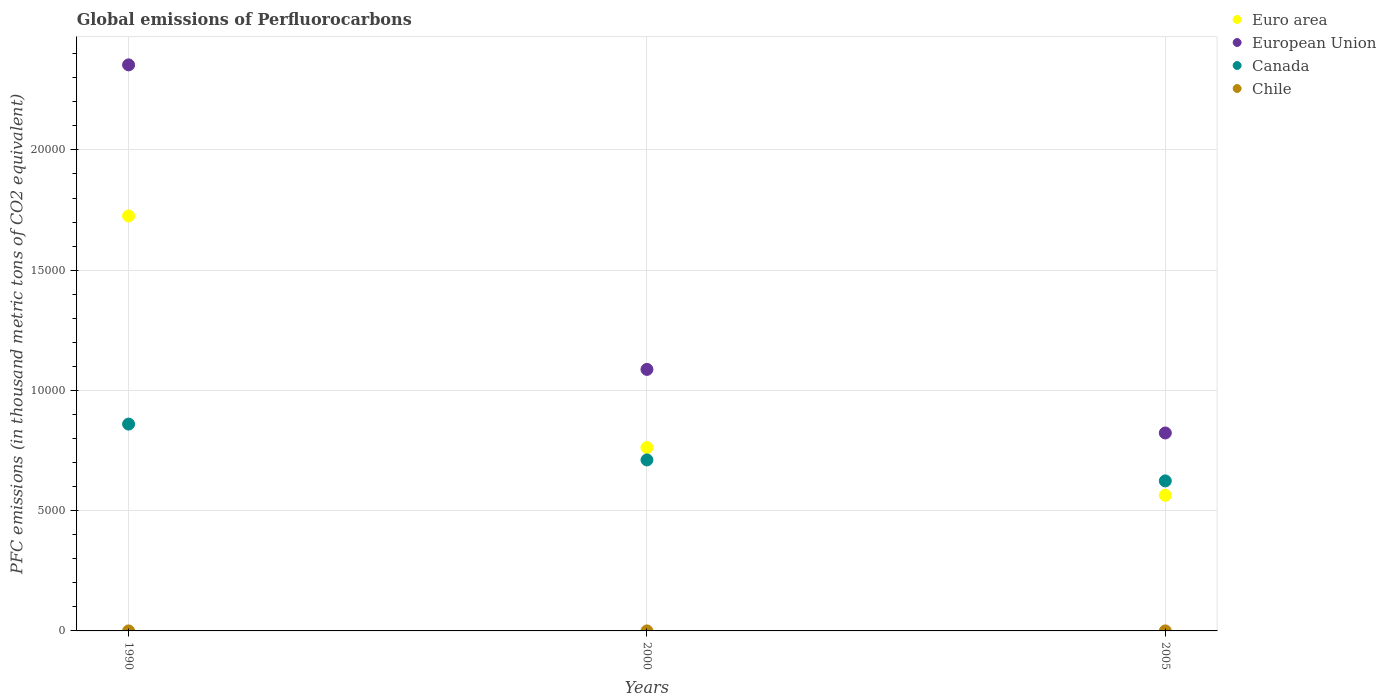What is the global emissions of Perfluorocarbons in Canada in 2005?
Make the answer very short. 6238. Across all years, what is the maximum global emissions of Perfluorocarbons in Canada?
Ensure brevity in your answer.  8600.3. What is the total global emissions of Perfluorocarbons in European Union in the graph?
Offer a very short reply. 4.26e+04. What is the difference between the global emissions of Perfluorocarbons in Canada in 1990 and that in 2005?
Ensure brevity in your answer.  2362.3. What is the difference between the global emissions of Perfluorocarbons in Chile in 1990 and the global emissions of Perfluorocarbons in European Union in 2005?
Offer a very short reply. -8230.59. What is the average global emissions of Perfluorocarbons in Canada per year?
Offer a very short reply. 7316.07. In the year 2000, what is the difference between the global emissions of Perfluorocarbons in Chile and global emissions of Perfluorocarbons in European Union?
Keep it short and to the point. -1.09e+04. What is the ratio of the global emissions of Perfluorocarbons in European Union in 2000 to that in 2005?
Your answer should be compact. 1.32. What is the difference between the highest and the second highest global emissions of Perfluorocarbons in Canada?
Offer a terse response. 1490.4. What is the difference between the highest and the lowest global emissions of Perfluorocarbons in Euro area?
Offer a terse response. 1.16e+04. Is it the case that in every year, the sum of the global emissions of Perfluorocarbons in Euro area and global emissions of Perfluorocarbons in Canada  is greater than the sum of global emissions of Perfluorocarbons in Chile and global emissions of Perfluorocarbons in European Union?
Make the answer very short. No. Is it the case that in every year, the sum of the global emissions of Perfluorocarbons in Canada and global emissions of Perfluorocarbons in Euro area  is greater than the global emissions of Perfluorocarbons in Chile?
Provide a short and direct response. Yes. Does the global emissions of Perfluorocarbons in Canada monotonically increase over the years?
Keep it short and to the point. No. Is the global emissions of Perfluorocarbons in Euro area strictly greater than the global emissions of Perfluorocarbons in European Union over the years?
Your answer should be compact. No. Is the global emissions of Perfluorocarbons in Euro area strictly less than the global emissions of Perfluorocarbons in Canada over the years?
Provide a succinct answer. No. How many dotlines are there?
Keep it short and to the point. 4. How many years are there in the graph?
Give a very brief answer. 3. Does the graph contain any zero values?
Offer a terse response. No. Where does the legend appear in the graph?
Offer a terse response. Top right. What is the title of the graph?
Keep it short and to the point. Global emissions of Perfluorocarbons. What is the label or title of the X-axis?
Make the answer very short. Years. What is the label or title of the Y-axis?
Offer a terse response. PFC emissions (in thousand metric tons of CO2 equivalent). What is the PFC emissions (in thousand metric tons of CO2 equivalent) in Euro area in 1990?
Your answer should be very brief. 1.73e+04. What is the PFC emissions (in thousand metric tons of CO2 equivalent) of European Union in 1990?
Your answer should be very brief. 2.35e+04. What is the PFC emissions (in thousand metric tons of CO2 equivalent) in Canada in 1990?
Keep it short and to the point. 8600.3. What is the PFC emissions (in thousand metric tons of CO2 equivalent) in Euro area in 2000?
Give a very brief answer. 7625. What is the PFC emissions (in thousand metric tons of CO2 equivalent) of European Union in 2000?
Make the answer very short. 1.09e+04. What is the PFC emissions (in thousand metric tons of CO2 equivalent) of Canada in 2000?
Offer a terse response. 7109.9. What is the PFC emissions (in thousand metric tons of CO2 equivalent) in Euro area in 2005?
Your answer should be very brief. 5640.06. What is the PFC emissions (in thousand metric tons of CO2 equivalent) of European Union in 2005?
Keep it short and to the point. 8230.79. What is the PFC emissions (in thousand metric tons of CO2 equivalent) of Canada in 2005?
Your response must be concise. 6238. Across all years, what is the maximum PFC emissions (in thousand metric tons of CO2 equivalent) in Euro area?
Offer a very short reply. 1.73e+04. Across all years, what is the maximum PFC emissions (in thousand metric tons of CO2 equivalent) of European Union?
Your response must be concise. 2.35e+04. Across all years, what is the maximum PFC emissions (in thousand metric tons of CO2 equivalent) of Canada?
Your answer should be compact. 8600.3. Across all years, what is the maximum PFC emissions (in thousand metric tons of CO2 equivalent) of Chile?
Provide a short and direct response. 0.2. Across all years, what is the minimum PFC emissions (in thousand metric tons of CO2 equivalent) of Euro area?
Make the answer very short. 5640.06. Across all years, what is the minimum PFC emissions (in thousand metric tons of CO2 equivalent) in European Union?
Your answer should be compact. 8230.79. Across all years, what is the minimum PFC emissions (in thousand metric tons of CO2 equivalent) of Canada?
Make the answer very short. 6238. What is the total PFC emissions (in thousand metric tons of CO2 equivalent) in Euro area in the graph?
Your answer should be compact. 3.05e+04. What is the total PFC emissions (in thousand metric tons of CO2 equivalent) of European Union in the graph?
Ensure brevity in your answer.  4.26e+04. What is the total PFC emissions (in thousand metric tons of CO2 equivalent) in Canada in the graph?
Offer a very short reply. 2.19e+04. What is the difference between the PFC emissions (in thousand metric tons of CO2 equivalent) of Euro area in 1990 and that in 2000?
Provide a succinct answer. 9630.1. What is the difference between the PFC emissions (in thousand metric tons of CO2 equivalent) in European Union in 1990 and that in 2000?
Offer a very short reply. 1.27e+04. What is the difference between the PFC emissions (in thousand metric tons of CO2 equivalent) in Canada in 1990 and that in 2000?
Your answer should be very brief. 1490.4. What is the difference between the PFC emissions (in thousand metric tons of CO2 equivalent) in Chile in 1990 and that in 2000?
Your answer should be very brief. 0. What is the difference between the PFC emissions (in thousand metric tons of CO2 equivalent) in Euro area in 1990 and that in 2005?
Ensure brevity in your answer.  1.16e+04. What is the difference between the PFC emissions (in thousand metric tons of CO2 equivalent) of European Union in 1990 and that in 2005?
Offer a very short reply. 1.53e+04. What is the difference between the PFC emissions (in thousand metric tons of CO2 equivalent) in Canada in 1990 and that in 2005?
Provide a succinct answer. 2362.3. What is the difference between the PFC emissions (in thousand metric tons of CO2 equivalent) in Chile in 1990 and that in 2005?
Make the answer very short. 0. What is the difference between the PFC emissions (in thousand metric tons of CO2 equivalent) of Euro area in 2000 and that in 2005?
Offer a terse response. 1984.94. What is the difference between the PFC emissions (in thousand metric tons of CO2 equivalent) in European Union in 2000 and that in 2005?
Ensure brevity in your answer.  2643.81. What is the difference between the PFC emissions (in thousand metric tons of CO2 equivalent) of Canada in 2000 and that in 2005?
Your answer should be very brief. 871.9. What is the difference between the PFC emissions (in thousand metric tons of CO2 equivalent) in Euro area in 1990 and the PFC emissions (in thousand metric tons of CO2 equivalent) in European Union in 2000?
Provide a succinct answer. 6380.5. What is the difference between the PFC emissions (in thousand metric tons of CO2 equivalent) of Euro area in 1990 and the PFC emissions (in thousand metric tons of CO2 equivalent) of Canada in 2000?
Your answer should be very brief. 1.01e+04. What is the difference between the PFC emissions (in thousand metric tons of CO2 equivalent) of Euro area in 1990 and the PFC emissions (in thousand metric tons of CO2 equivalent) of Chile in 2000?
Your answer should be compact. 1.73e+04. What is the difference between the PFC emissions (in thousand metric tons of CO2 equivalent) of European Union in 1990 and the PFC emissions (in thousand metric tons of CO2 equivalent) of Canada in 2000?
Offer a very short reply. 1.64e+04. What is the difference between the PFC emissions (in thousand metric tons of CO2 equivalent) of European Union in 1990 and the PFC emissions (in thousand metric tons of CO2 equivalent) of Chile in 2000?
Provide a short and direct response. 2.35e+04. What is the difference between the PFC emissions (in thousand metric tons of CO2 equivalent) of Canada in 1990 and the PFC emissions (in thousand metric tons of CO2 equivalent) of Chile in 2000?
Offer a very short reply. 8600.1. What is the difference between the PFC emissions (in thousand metric tons of CO2 equivalent) of Euro area in 1990 and the PFC emissions (in thousand metric tons of CO2 equivalent) of European Union in 2005?
Keep it short and to the point. 9024.31. What is the difference between the PFC emissions (in thousand metric tons of CO2 equivalent) of Euro area in 1990 and the PFC emissions (in thousand metric tons of CO2 equivalent) of Canada in 2005?
Give a very brief answer. 1.10e+04. What is the difference between the PFC emissions (in thousand metric tons of CO2 equivalent) in Euro area in 1990 and the PFC emissions (in thousand metric tons of CO2 equivalent) in Chile in 2005?
Your response must be concise. 1.73e+04. What is the difference between the PFC emissions (in thousand metric tons of CO2 equivalent) in European Union in 1990 and the PFC emissions (in thousand metric tons of CO2 equivalent) in Canada in 2005?
Your answer should be compact. 1.73e+04. What is the difference between the PFC emissions (in thousand metric tons of CO2 equivalent) in European Union in 1990 and the PFC emissions (in thousand metric tons of CO2 equivalent) in Chile in 2005?
Your answer should be compact. 2.35e+04. What is the difference between the PFC emissions (in thousand metric tons of CO2 equivalent) in Canada in 1990 and the PFC emissions (in thousand metric tons of CO2 equivalent) in Chile in 2005?
Your response must be concise. 8600.1. What is the difference between the PFC emissions (in thousand metric tons of CO2 equivalent) in Euro area in 2000 and the PFC emissions (in thousand metric tons of CO2 equivalent) in European Union in 2005?
Keep it short and to the point. -605.79. What is the difference between the PFC emissions (in thousand metric tons of CO2 equivalent) in Euro area in 2000 and the PFC emissions (in thousand metric tons of CO2 equivalent) in Canada in 2005?
Make the answer very short. 1387. What is the difference between the PFC emissions (in thousand metric tons of CO2 equivalent) of Euro area in 2000 and the PFC emissions (in thousand metric tons of CO2 equivalent) of Chile in 2005?
Your response must be concise. 7624.8. What is the difference between the PFC emissions (in thousand metric tons of CO2 equivalent) of European Union in 2000 and the PFC emissions (in thousand metric tons of CO2 equivalent) of Canada in 2005?
Make the answer very short. 4636.6. What is the difference between the PFC emissions (in thousand metric tons of CO2 equivalent) of European Union in 2000 and the PFC emissions (in thousand metric tons of CO2 equivalent) of Chile in 2005?
Your answer should be compact. 1.09e+04. What is the difference between the PFC emissions (in thousand metric tons of CO2 equivalent) of Canada in 2000 and the PFC emissions (in thousand metric tons of CO2 equivalent) of Chile in 2005?
Provide a short and direct response. 7109.7. What is the average PFC emissions (in thousand metric tons of CO2 equivalent) of Euro area per year?
Provide a succinct answer. 1.02e+04. What is the average PFC emissions (in thousand metric tons of CO2 equivalent) of European Union per year?
Provide a succinct answer. 1.42e+04. What is the average PFC emissions (in thousand metric tons of CO2 equivalent) of Canada per year?
Provide a succinct answer. 7316.07. What is the average PFC emissions (in thousand metric tons of CO2 equivalent) in Chile per year?
Ensure brevity in your answer.  0.2. In the year 1990, what is the difference between the PFC emissions (in thousand metric tons of CO2 equivalent) of Euro area and PFC emissions (in thousand metric tons of CO2 equivalent) of European Union?
Provide a succinct answer. -6281.4. In the year 1990, what is the difference between the PFC emissions (in thousand metric tons of CO2 equivalent) in Euro area and PFC emissions (in thousand metric tons of CO2 equivalent) in Canada?
Your response must be concise. 8654.8. In the year 1990, what is the difference between the PFC emissions (in thousand metric tons of CO2 equivalent) of Euro area and PFC emissions (in thousand metric tons of CO2 equivalent) of Chile?
Provide a short and direct response. 1.73e+04. In the year 1990, what is the difference between the PFC emissions (in thousand metric tons of CO2 equivalent) of European Union and PFC emissions (in thousand metric tons of CO2 equivalent) of Canada?
Provide a succinct answer. 1.49e+04. In the year 1990, what is the difference between the PFC emissions (in thousand metric tons of CO2 equivalent) of European Union and PFC emissions (in thousand metric tons of CO2 equivalent) of Chile?
Your answer should be very brief. 2.35e+04. In the year 1990, what is the difference between the PFC emissions (in thousand metric tons of CO2 equivalent) in Canada and PFC emissions (in thousand metric tons of CO2 equivalent) in Chile?
Provide a short and direct response. 8600.1. In the year 2000, what is the difference between the PFC emissions (in thousand metric tons of CO2 equivalent) of Euro area and PFC emissions (in thousand metric tons of CO2 equivalent) of European Union?
Your answer should be very brief. -3249.6. In the year 2000, what is the difference between the PFC emissions (in thousand metric tons of CO2 equivalent) in Euro area and PFC emissions (in thousand metric tons of CO2 equivalent) in Canada?
Provide a short and direct response. 515.1. In the year 2000, what is the difference between the PFC emissions (in thousand metric tons of CO2 equivalent) in Euro area and PFC emissions (in thousand metric tons of CO2 equivalent) in Chile?
Offer a terse response. 7624.8. In the year 2000, what is the difference between the PFC emissions (in thousand metric tons of CO2 equivalent) of European Union and PFC emissions (in thousand metric tons of CO2 equivalent) of Canada?
Provide a succinct answer. 3764.7. In the year 2000, what is the difference between the PFC emissions (in thousand metric tons of CO2 equivalent) of European Union and PFC emissions (in thousand metric tons of CO2 equivalent) of Chile?
Provide a short and direct response. 1.09e+04. In the year 2000, what is the difference between the PFC emissions (in thousand metric tons of CO2 equivalent) of Canada and PFC emissions (in thousand metric tons of CO2 equivalent) of Chile?
Offer a terse response. 7109.7. In the year 2005, what is the difference between the PFC emissions (in thousand metric tons of CO2 equivalent) of Euro area and PFC emissions (in thousand metric tons of CO2 equivalent) of European Union?
Make the answer very short. -2590.74. In the year 2005, what is the difference between the PFC emissions (in thousand metric tons of CO2 equivalent) of Euro area and PFC emissions (in thousand metric tons of CO2 equivalent) of Canada?
Make the answer very short. -597.94. In the year 2005, what is the difference between the PFC emissions (in thousand metric tons of CO2 equivalent) in Euro area and PFC emissions (in thousand metric tons of CO2 equivalent) in Chile?
Ensure brevity in your answer.  5639.86. In the year 2005, what is the difference between the PFC emissions (in thousand metric tons of CO2 equivalent) in European Union and PFC emissions (in thousand metric tons of CO2 equivalent) in Canada?
Offer a terse response. 1992.79. In the year 2005, what is the difference between the PFC emissions (in thousand metric tons of CO2 equivalent) in European Union and PFC emissions (in thousand metric tons of CO2 equivalent) in Chile?
Your response must be concise. 8230.59. In the year 2005, what is the difference between the PFC emissions (in thousand metric tons of CO2 equivalent) in Canada and PFC emissions (in thousand metric tons of CO2 equivalent) in Chile?
Your answer should be compact. 6237.8. What is the ratio of the PFC emissions (in thousand metric tons of CO2 equivalent) of Euro area in 1990 to that in 2000?
Make the answer very short. 2.26. What is the ratio of the PFC emissions (in thousand metric tons of CO2 equivalent) in European Union in 1990 to that in 2000?
Give a very brief answer. 2.16. What is the ratio of the PFC emissions (in thousand metric tons of CO2 equivalent) in Canada in 1990 to that in 2000?
Your answer should be compact. 1.21. What is the ratio of the PFC emissions (in thousand metric tons of CO2 equivalent) of Euro area in 1990 to that in 2005?
Offer a very short reply. 3.06. What is the ratio of the PFC emissions (in thousand metric tons of CO2 equivalent) of European Union in 1990 to that in 2005?
Give a very brief answer. 2.86. What is the ratio of the PFC emissions (in thousand metric tons of CO2 equivalent) of Canada in 1990 to that in 2005?
Provide a short and direct response. 1.38. What is the ratio of the PFC emissions (in thousand metric tons of CO2 equivalent) in Euro area in 2000 to that in 2005?
Ensure brevity in your answer.  1.35. What is the ratio of the PFC emissions (in thousand metric tons of CO2 equivalent) in European Union in 2000 to that in 2005?
Your response must be concise. 1.32. What is the ratio of the PFC emissions (in thousand metric tons of CO2 equivalent) in Canada in 2000 to that in 2005?
Keep it short and to the point. 1.14. What is the ratio of the PFC emissions (in thousand metric tons of CO2 equivalent) of Chile in 2000 to that in 2005?
Your answer should be very brief. 1. What is the difference between the highest and the second highest PFC emissions (in thousand metric tons of CO2 equivalent) in Euro area?
Your response must be concise. 9630.1. What is the difference between the highest and the second highest PFC emissions (in thousand metric tons of CO2 equivalent) of European Union?
Make the answer very short. 1.27e+04. What is the difference between the highest and the second highest PFC emissions (in thousand metric tons of CO2 equivalent) of Canada?
Give a very brief answer. 1490.4. What is the difference between the highest and the lowest PFC emissions (in thousand metric tons of CO2 equivalent) in Euro area?
Provide a succinct answer. 1.16e+04. What is the difference between the highest and the lowest PFC emissions (in thousand metric tons of CO2 equivalent) in European Union?
Your response must be concise. 1.53e+04. What is the difference between the highest and the lowest PFC emissions (in thousand metric tons of CO2 equivalent) of Canada?
Make the answer very short. 2362.3. 